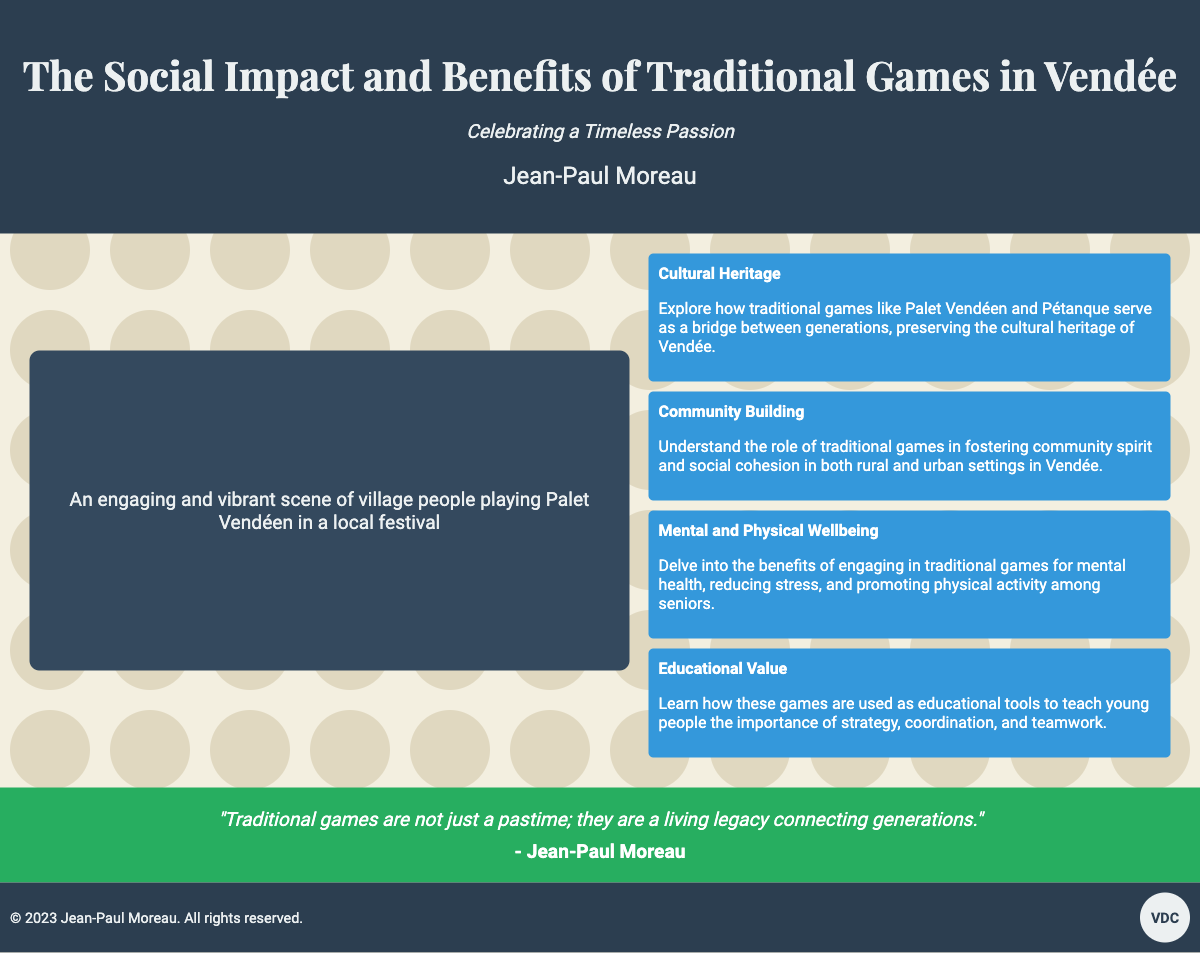What is the title of the book? The title of the book is prominently displayed in the header section.
Answer: The Social Impact and Benefits of Traditional Games in Vendée Who is the author of the book? The author's name is listed beneath the title.
Answer: Jean-Paul Moreau What traditional game is mentioned in the cultural heritage highlight? The cultural heritage highlight specifically mentions one traditional game.
Answer: Palet Vendéen What is the main benefit linked to traditional games for seniors? The highlight about mental and physical wellbeing outlines the benefits for seniors.
Answer: Reducing stress How many highlights are presented in the document? There are multiple highlight sections presented in the main content area.
Answer: Four In what year was this book published? The year of publication is included in the footer section.
Answer: 2023 What is the subtitle of the book? The subtitle is presented just below the title.
Answer: Celebrating a Timeless Passion What is the primary theme of the quote included in the document? The quote relates to the importance of traditional games in connecting generations.
Answer: A living legacy 